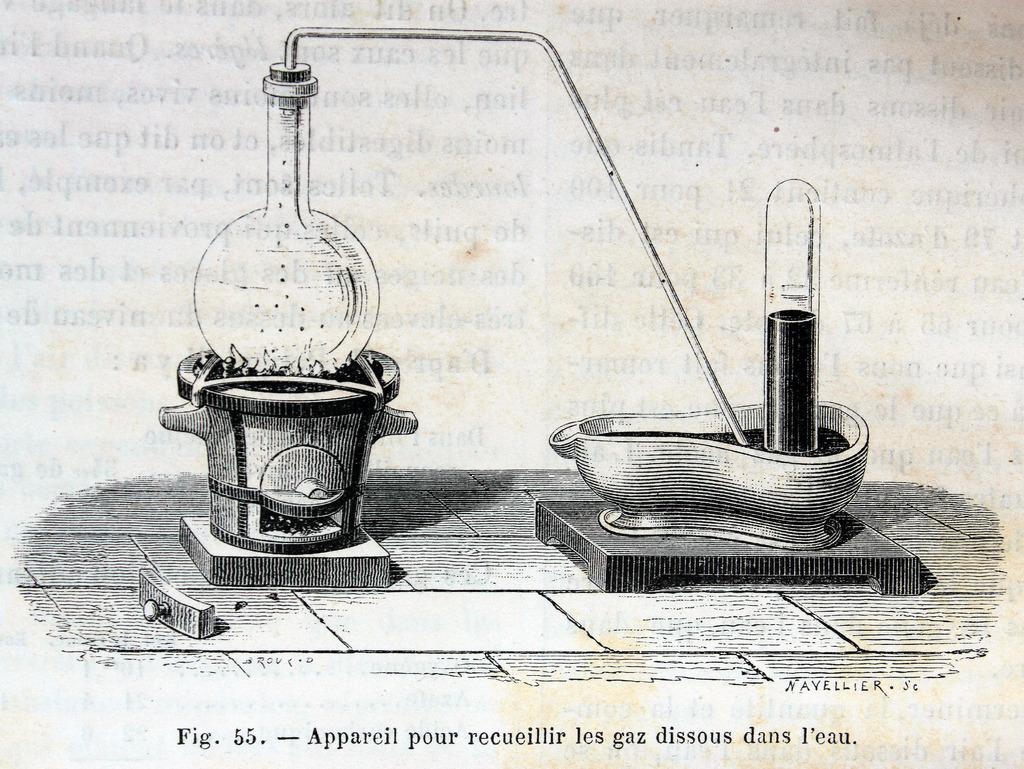<image>
Relay a brief, clear account of the picture shown. Figure 55 is a drawing of a chemistry experiment. 